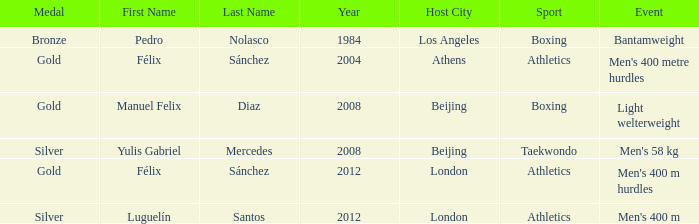Which Medal had a Games of 2008 beijing, and a Sport of taekwondo? Silver. Give me the full table as a dictionary. {'header': ['Medal', 'First Name', 'Last Name', 'Year', 'Host City', 'Sport', 'Event'], 'rows': [['Bronze', 'Pedro', 'Nolasco', '1984', 'Los Angeles', 'Boxing', 'Bantamweight'], ['Gold', 'Félix', 'Sánchez', '2004', 'Athens', 'Athletics', "Men's 400 metre hurdles"], ['Gold', 'Manuel Felix', 'Diaz', '2008', 'Beijing', 'Boxing', 'Light welterweight'], ['Silver', 'Yulis Gabriel', 'Mercedes', '2008', 'Beijing', 'Taekwondo', "Men's 58 kg"], ['Gold', 'Félix', 'Sánchez', '2012', 'London', 'Athletics', "Men's 400 m hurdles"], ['Silver', 'Luguelín', 'Santos', '2012', 'London', 'Athletics', "Men's 400 m"]]} 